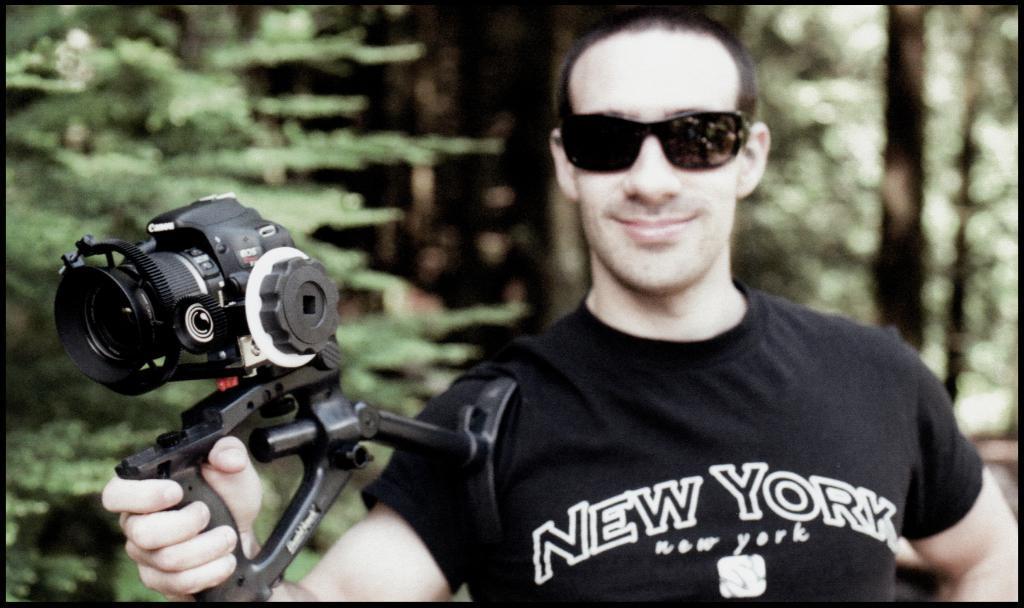Describe this image in one or two sentences. In the foreground of this picture, there is a man in black T shirt holding a camera in his hand and also wearing black spectacles. In the background, there are trees. 